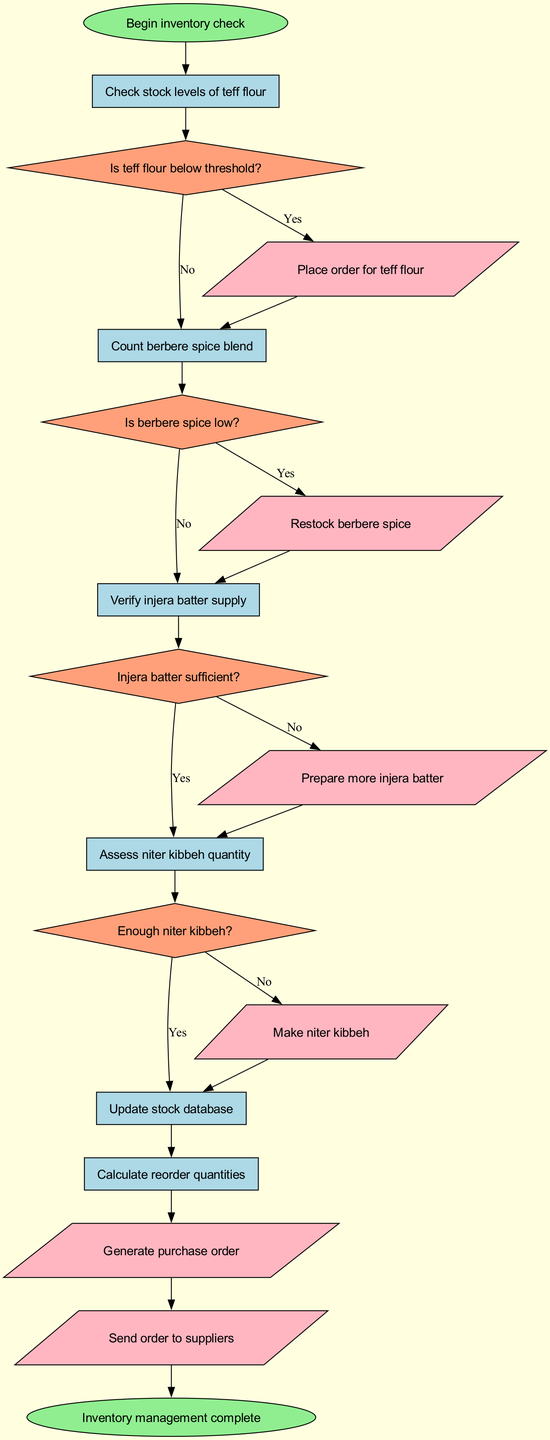What is the first process after starting the inventory check? The flow starts with the "Check stock levels of teff flour" process immediately after the start node, as indicated by the flowchart's first connection.
Answer: Check stock levels of teff flour How many decision nodes are in the diagram? The diagram contains four decision nodes: "Is teff flour below threshold?", "Is berbere spice low?", "Injera batter sufficient?", and "Enough niter kibbeh?" which can be counted directly from the diagram.
Answer: Four What happens if teff flour is below the threshold? If teff flour is below the threshold, the flowchart indicates that the next step is to take the action "Place order for teff flour". This is established by following the "Yes" path from the decision node.
Answer: Place order for teff flour Which action is taken if the injera batter is sufficient? According to the flowchart, if the injera batter is sufficient, the flow progresses to the next decision without any action, resulting in no action being taken at that point."
Answer: No action What is the last action before the inventory management is complete? The last action before reaching the end node is "Send order to suppliers", as it's the final step after generating the purchase order and before the inventory process is marked complete.
Answer: Send order to suppliers If berbere spice is low, which action follows? If berbere spice is low, the action indicated by the "Yes" path from the decision node is to "Restock berbere spice", thus determining the next immediate step in the flow.
Answer: Restock berbere spice What is the relationship between checking stock levels of teff flour and assessing niter kibbeh quantity? The relationship is sequential; after checking stock levels of teff flour, if it is not below threshold, the flow continues to check the next item, which is assessing niter kibbeh quantity. This shows a direct progression in inventory checks.
Answer: Sequential Which process follows the action of preparing more injera batter? The next process that follows the action of preparing more injera batter is "Make niter kibbeh", as per the defined flow that connects actions and shows the proceeding steps.
Answer: Make niter kibbeh 